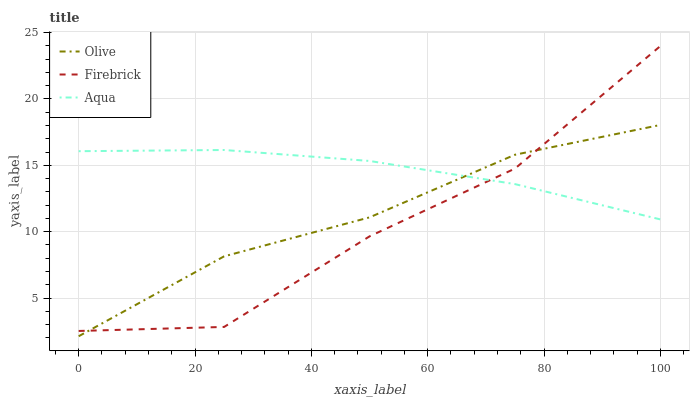Does Firebrick have the minimum area under the curve?
Answer yes or no. Yes. Does Aqua have the maximum area under the curve?
Answer yes or no. Yes. Does Aqua have the minimum area under the curve?
Answer yes or no. No. Does Firebrick have the maximum area under the curve?
Answer yes or no. No. Is Aqua the smoothest?
Answer yes or no. Yes. Is Firebrick the roughest?
Answer yes or no. Yes. Is Firebrick the smoothest?
Answer yes or no. No. Is Aqua the roughest?
Answer yes or no. No. Does Olive have the lowest value?
Answer yes or no. Yes. Does Firebrick have the lowest value?
Answer yes or no. No. Does Firebrick have the highest value?
Answer yes or no. Yes. Does Aqua have the highest value?
Answer yes or no. No. Does Aqua intersect Firebrick?
Answer yes or no. Yes. Is Aqua less than Firebrick?
Answer yes or no. No. Is Aqua greater than Firebrick?
Answer yes or no. No. 